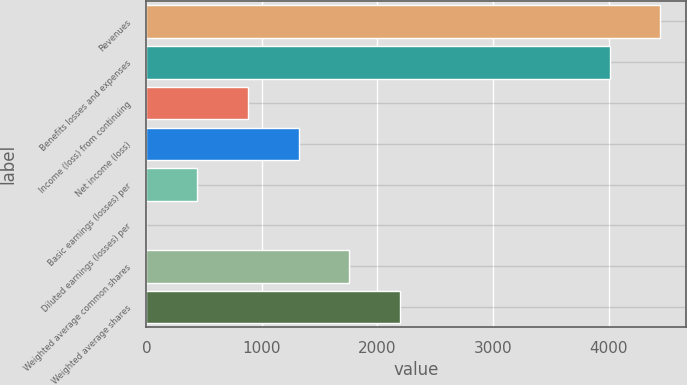Convert chart. <chart><loc_0><loc_0><loc_500><loc_500><bar_chart><fcel>Revenues<fcel>Benefits losses and expenses<fcel>Income (loss) from continuing<fcel>Net income (loss)<fcel>Basic earnings (losses) per<fcel>Diluted earnings (losses) per<fcel>Weighted average common shares<fcel>Weighted average shares<nl><fcel>4449.02<fcel>4010<fcel>878.83<fcel>1317.85<fcel>439.81<fcel>0.79<fcel>1756.87<fcel>2195.89<nl></chart> 